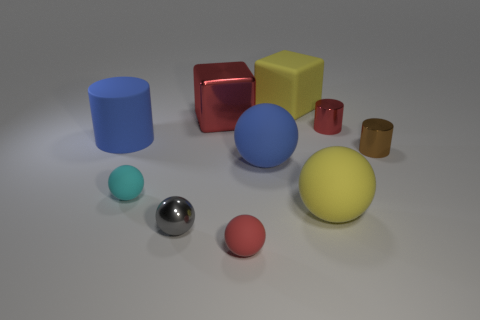There is a metal cylinder that is the same size as the brown shiny object; what color is it?
Offer a terse response. Red. Are there any other things that are the same color as the large cylinder?
Your answer should be very brief. Yes. Does the yellow thing that is behind the small brown metal thing have the same material as the large yellow sphere?
Provide a short and direct response. Yes. How many things are both on the right side of the big yellow matte sphere and behind the blue cylinder?
Your answer should be very brief. 1. What is the size of the cylinder that is left of the yellow rubber object behind the large red object?
Your answer should be compact. Large. Is the number of big blue rubber cylinders greater than the number of small brown rubber balls?
Provide a succinct answer. Yes. There is a big shiny object that is left of the small brown metal cylinder; is its color the same as the thing right of the small red shiny object?
Ensure brevity in your answer.  No. Is there a blue object that is left of the tiny red thing that is on the left side of the big yellow ball?
Provide a short and direct response. Yes. Is the number of blue rubber things that are in front of the matte cylinder less than the number of small red matte spheres that are behind the small cyan rubber ball?
Your answer should be compact. No. Is the material of the tiny sphere that is on the right side of the large red object the same as the blue object left of the small gray metal sphere?
Give a very brief answer. Yes. 